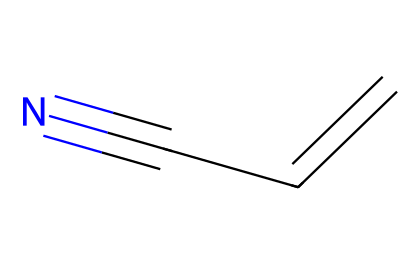What is the molecular formula of acrylonitrile? The molecular formula is obtained by counting the number of carbon (C), hydrogen (H), and nitrogen (N) atoms in the structure. The structure shows 3 carbon atoms, 3 hydrogen atoms, and 1 nitrogen atom, leading to the formula C3H3N.
Answer: C3H3N How many double bonds are present in acrylonitrile? By examining the structure, one double bond is identified between the first two carbon atoms (C=C). There are no other double bonds in the molecule.
Answer: 1 What functional group characterizes acrylonitrile? The structural representation shows a cyano group (–C≡N) attached to the carbon chain. This group is typical for nitriles and is what characterizes acrylonitrile.
Answer: cyano What is the total number of atoms in acrylonitrile? To find the total number of atoms, count all atoms represented: 3 carbon, 3 hydrogen, and 1 nitrogen gives a total of 7 atoms.
Answer: 7 Which type of hybridization do the carbons in acrylonitrile exhibit? The first carbon (in the double bond) exhibits sp2 hybridization due to the presence of a double bond, while the third carbon, which is triple-bonded to nitrogen, exhibits sp hybridization. This variation reflects the nature of the bonding present.
Answer: sp2 and sp What is the key property of acrylonitrile that makes it suitable for synthetic strings? Acrylonitrile has excellent toughness and resistance to wear due to its molecular structure. This property aids in the durability required for high-performance tennis racket strings.
Answer: toughness 